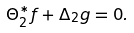<formula> <loc_0><loc_0><loc_500><loc_500>\Theta _ { 2 } ^ { * } f + \Delta _ { 2 } g = 0 .</formula> 